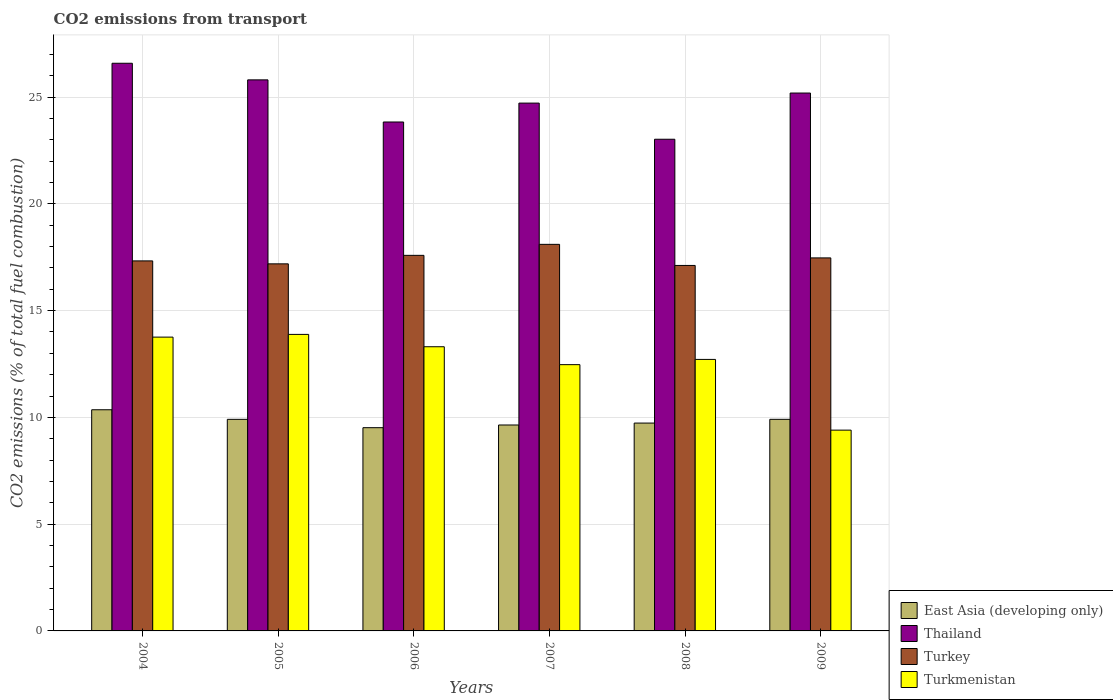How many different coloured bars are there?
Your response must be concise. 4. Are the number of bars per tick equal to the number of legend labels?
Make the answer very short. Yes. How many bars are there on the 5th tick from the left?
Make the answer very short. 4. How many bars are there on the 3rd tick from the right?
Offer a very short reply. 4. What is the label of the 6th group of bars from the left?
Give a very brief answer. 2009. In how many cases, is the number of bars for a given year not equal to the number of legend labels?
Your response must be concise. 0. What is the total CO2 emitted in Thailand in 2007?
Make the answer very short. 24.72. Across all years, what is the maximum total CO2 emitted in Turkey?
Offer a terse response. 18.1. Across all years, what is the minimum total CO2 emitted in Turkey?
Your answer should be very brief. 17.11. In which year was the total CO2 emitted in Thailand maximum?
Keep it short and to the point. 2004. What is the total total CO2 emitted in Turkmenistan in the graph?
Ensure brevity in your answer.  75.53. What is the difference between the total CO2 emitted in East Asia (developing only) in 2004 and that in 2008?
Give a very brief answer. 0.62. What is the difference between the total CO2 emitted in Turkmenistan in 2008 and the total CO2 emitted in East Asia (developing only) in 2005?
Your response must be concise. 2.81. What is the average total CO2 emitted in Turkey per year?
Ensure brevity in your answer.  17.46. In the year 2007, what is the difference between the total CO2 emitted in East Asia (developing only) and total CO2 emitted in Turkey?
Provide a short and direct response. -8.46. What is the ratio of the total CO2 emitted in Turkmenistan in 2004 to that in 2009?
Offer a very short reply. 1.46. Is the total CO2 emitted in East Asia (developing only) in 2005 less than that in 2009?
Ensure brevity in your answer.  Yes. What is the difference between the highest and the second highest total CO2 emitted in Turkey?
Ensure brevity in your answer.  0.52. What is the difference between the highest and the lowest total CO2 emitted in Thailand?
Keep it short and to the point. 3.56. In how many years, is the total CO2 emitted in Turkmenistan greater than the average total CO2 emitted in Turkmenistan taken over all years?
Offer a terse response. 4. Is the sum of the total CO2 emitted in Turkmenistan in 2005 and 2007 greater than the maximum total CO2 emitted in Turkey across all years?
Keep it short and to the point. Yes. Is it the case that in every year, the sum of the total CO2 emitted in Turkey and total CO2 emitted in East Asia (developing only) is greater than the sum of total CO2 emitted in Turkmenistan and total CO2 emitted in Thailand?
Keep it short and to the point. No. What does the 1st bar from the left in 2004 represents?
Provide a succinct answer. East Asia (developing only). What does the 4th bar from the right in 2005 represents?
Make the answer very short. East Asia (developing only). How many bars are there?
Give a very brief answer. 24. Are all the bars in the graph horizontal?
Ensure brevity in your answer.  No. How many years are there in the graph?
Provide a succinct answer. 6. Are the values on the major ticks of Y-axis written in scientific E-notation?
Offer a terse response. No. Where does the legend appear in the graph?
Your response must be concise. Bottom right. How many legend labels are there?
Provide a short and direct response. 4. What is the title of the graph?
Provide a succinct answer. CO2 emissions from transport. Does "Czech Republic" appear as one of the legend labels in the graph?
Offer a terse response. No. What is the label or title of the Y-axis?
Your answer should be compact. CO2 emissions (% of total fuel combustion). What is the CO2 emissions (% of total fuel combustion) in East Asia (developing only) in 2004?
Your response must be concise. 10.36. What is the CO2 emissions (% of total fuel combustion) of Thailand in 2004?
Your answer should be very brief. 26.58. What is the CO2 emissions (% of total fuel combustion) in Turkey in 2004?
Ensure brevity in your answer.  17.33. What is the CO2 emissions (% of total fuel combustion) in Turkmenistan in 2004?
Your answer should be very brief. 13.76. What is the CO2 emissions (% of total fuel combustion) in East Asia (developing only) in 2005?
Give a very brief answer. 9.91. What is the CO2 emissions (% of total fuel combustion) in Thailand in 2005?
Your answer should be compact. 25.8. What is the CO2 emissions (% of total fuel combustion) of Turkey in 2005?
Your answer should be compact. 17.19. What is the CO2 emissions (% of total fuel combustion) in Turkmenistan in 2005?
Give a very brief answer. 13.89. What is the CO2 emissions (% of total fuel combustion) of East Asia (developing only) in 2006?
Offer a terse response. 9.52. What is the CO2 emissions (% of total fuel combustion) of Thailand in 2006?
Give a very brief answer. 23.83. What is the CO2 emissions (% of total fuel combustion) of Turkey in 2006?
Make the answer very short. 17.59. What is the CO2 emissions (% of total fuel combustion) of Turkmenistan in 2006?
Give a very brief answer. 13.31. What is the CO2 emissions (% of total fuel combustion) of East Asia (developing only) in 2007?
Keep it short and to the point. 9.64. What is the CO2 emissions (% of total fuel combustion) in Thailand in 2007?
Provide a short and direct response. 24.72. What is the CO2 emissions (% of total fuel combustion) in Turkey in 2007?
Your answer should be compact. 18.1. What is the CO2 emissions (% of total fuel combustion) of Turkmenistan in 2007?
Your response must be concise. 12.47. What is the CO2 emissions (% of total fuel combustion) in East Asia (developing only) in 2008?
Your response must be concise. 9.73. What is the CO2 emissions (% of total fuel combustion) in Thailand in 2008?
Your response must be concise. 23.02. What is the CO2 emissions (% of total fuel combustion) in Turkey in 2008?
Your answer should be compact. 17.11. What is the CO2 emissions (% of total fuel combustion) in Turkmenistan in 2008?
Your answer should be compact. 12.71. What is the CO2 emissions (% of total fuel combustion) in East Asia (developing only) in 2009?
Ensure brevity in your answer.  9.91. What is the CO2 emissions (% of total fuel combustion) of Thailand in 2009?
Give a very brief answer. 25.19. What is the CO2 emissions (% of total fuel combustion) of Turkey in 2009?
Ensure brevity in your answer.  17.47. What is the CO2 emissions (% of total fuel combustion) of Turkmenistan in 2009?
Provide a short and direct response. 9.4. Across all years, what is the maximum CO2 emissions (% of total fuel combustion) of East Asia (developing only)?
Your answer should be very brief. 10.36. Across all years, what is the maximum CO2 emissions (% of total fuel combustion) in Thailand?
Your answer should be very brief. 26.58. Across all years, what is the maximum CO2 emissions (% of total fuel combustion) in Turkey?
Offer a very short reply. 18.1. Across all years, what is the maximum CO2 emissions (% of total fuel combustion) in Turkmenistan?
Your answer should be compact. 13.89. Across all years, what is the minimum CO2 emissions (% of total fuel combustion) in East Asia (developing only)?
Provide a short and direct response. 9.52. Across all years, what is the minimum CO2 emissions (% of total fuel combustion) in Thailand?
Your response must be concise. 23.02. Across all years, what is the minimum CO2 emissions (% of total fuel combustion) of Turkey?
Offer a terse response. 17.11. Across all years, what is the minimum CO2 emissions (% of total fuel combustion) in Turkmenistan?
Provide a succinct answer. 9.4. What is the total CO2 emissions (% of total fuel combustion) of East Asia (developing only) in the graph?
Offer a terse response. 59.07. What is the total CO2 emissions (% of total fuel combustion) in Thailand in the graph?
Give a very brief answer. 149.14. What is the total CO2 emissions (% of total fuel combustion) in Turkey in the graph?
Give a very brief answer. 104.79. What is the total CO2 emissions (% of total fuel combustion) of Turkmenistan in the graph?
Provide a succinct answer. 75.53. What is the difference between the CO2 emissions (% of total fuel combustion) of East Asia (developing only) in 2004 and that in 2005?
Keep it short and to the point. 0.45. What is the difference between the CO2 emissions (% of total fuel combustion) in Thailand in 2004 and that in 2005?
Your answer should be very brief. 0.78. What is the difference between the CO2 emissions (% of total fuel combustion) of Turkey in 2004 and that in 2005?
Offer a very short reply. 0.14. What is the difference between the CO2 emissions (% of total fuel combustion) in Turkmenistan in 2004 and that in 2005?
Make the answer very short. -0.13. What is the difference between the CO2 emissions (% of total fuel combustion) in East Asia (developing only) in 2004 and that in 2006?
Offer a terse response. 0.84. What is the difference between the CO2 emissions (% of total fuel combustion) in Thailand in 2004 and that in 2006?
Give a very brief answer. 2.75. What is the difference between the CO2 emissions (% of total fuel combustion) in Turkey in 2004 and that in 2006?
Your answer should be very brief. -0.26. What is the difference between the CO2 emissions (% of total fuel combustion) in Turkmenistan in 2004 and that in 2006?
Keep it short and to the point. 0.45. What is the difference between the CO2 emissions (% of total fuel combustion) of East Asia (developing only) in 2004 and that in 2007?
Your answer should be very brief. 0.71. What is the difference between the CO2 emissions (% of total fuel combustion) of Thailand in 2004 and that in 2007?
Offer a very short reply. 1.87. What is the difference between the CO2 emissions (% of total fuel combustion) in Turkey in 2004 and that in 2007?
Your answer should be compact. -0.78. What is the difference between the CO2 emissions (% of total fuel combustion) in Turkmenistan in 2004 and that in 2007?
Provide a short and direct response. 1.29. What is the difference between the CO2 emissions (% of total fuel combustion) in East Asia (developing only) in 2004 and that in 2008?
Provide a succinct answer. 0.62. What is the difference between the CO2 emissions (% of total fuel combustion) of Thailand in 2004 and that in 2008?
Your response must be concise. 3.56. What is the difference between the CO2 emissions (% of total fuel combustion) of Turkey in 2004 and that in 2008?
Provide a short and direct response. 0.21. What is the difference between the CO2 emissions (% of total fuel combustion) in Turkmenistan in 2004 and that in 2008?
Your answer should be very brief. 1.04. What is the difference between the CO2 emissions (% of total fuel combustion) of East Asia (developing only) in 2004 and that in 2009?
Your answer should be compact. 0.45. What is the difference between the CO2 emissions (% of total fuel combustion) in Thailand in 2004 and that in 2009?
Your answer should be compact. 1.39. What is the difference between the CO2 emissions (% of total fuel combustion) in Turkey in 2004 and that in 2009?
Your answer should be compact. -0.14. What is the difference between the CO2 emissions (% of total fuel combustion) of Turkmenistan in 2004 and that in 2009?
Ensure brevity in your answer.  4.36. What is the difference between the CO2 emissions (% of total fuel combustion) in East Asia (developing only) in 2005 and that in 2006?
Keep it short and to the point. 0.39. What is the difference between the CO2 emissions (% of total fuel combustion) in Thailand in 2005 and that in 2006?
Offer a terse response. 1.97. What is the difference between the CO2 emissions (% of total fuel combustion) in Turkey in 2005 and that in 2006?
Ensure brevity in your answer.  -0.4. What is the difference between the CO2 emissions (% of total fuel combustion) of Turkmenistan in 2005 and that in 2006?
Provide a short and direct response. 0.58. What is the difference between the CO2 emissions (% of total fuel combustion) in East Asia (developing only) in 2005 and that in 2007?
Your answer should be compact. 0.26. What is the difference between the CO2 emissions (% of total fuel combustion) in Thailand in 2005 and that in 2007?
Provide a short and direct response. 1.09. What is the difference between the CO2 emissions (% of total fuel combustion) in Turkey in 2005 and that in 2007?
Make the answer very short. -0.91. What is the difference between the CO2 emissions (% of total fuel combustion) of Turkmenistan in 2005 and that in 2007?
Ensure brevity in your answer.  1.42. What is the difference between the CO2 emissions (% of total fuel combustion) in East Asia (developing only) in 2005 and that in 2008?
Offer a terse response. 0.17. What is the difference between the CO2 emissions (% of total fuel combustion) of Thailand in 2005 and that in 2008?
Give a very brief answer. 2.78. What is the difference between the CO2 emissions (% of total fuel combustion) of Turkey in 2005 and that in 2008?
Offer a very short reply. 0.08. What is the difference between the CO2 emissions (% of total fuel combustion) in Turkmenistan in 2005 and that in 2008?
Provide a succinct answer. 1.17. What is the difference between the CO2 emissions (% of total fuel combustion) of East Asia (developing only) in 2005 and that in 2009?
Offer a very short reply. -0. What is the difference between the CO2 emissions (% of total fuel combustion) in Thailand in 2005 and that in 2009?
Your answer should be compact. 0.62. What is the difference between the CO2 emissions (% of total fuel combustion) of Turkey in 2005 and that in 2009?
Your response must be concise. -0.28. What is the difference between the CO2 emissions (% of total fuel combustion) of Turkmenistan in 2005 and that in 2009?
Your answer should be compact. 4.48. What is the difference between the CO2 emissions (% of total fuel combustion) in East Asia (developing only) in 2006 and that in 2007?
Offer a terse response. -0.13. What is the difference between the CO2 emissions (% of total fuel combustion) of Thailand in 2006 and that in 2007?
Your answer should be very brief. -0.88. What is the difference between the CO2 emissions (% of total fuel combustion) in Turkey in 2006 and that in 2007?
Provide a succinct answer. -0.52. What is the difference between the CO2 emissions (% of total fuel combustion) in Turkmenistan in 2006 and that in 2007?
Provide a succinct answer. 0.84. What is the difference between the CO2 emissions (% of total fuel combustion) of East Asia (developing only) in 2006 and that in 2008?
Provide a short and direct response. -0.22. What is the difference between the CO2 emissions (% of total fuel combustion) in Thailand in 2006 and that in 2008?
Ensure brevity in your answer.  0.81. What is the difference between the CO2 emissions (% of total fuel combustion) of Turkey in 2006 and that in 2008?
Your response must be concise. 0.47. What is the difference between the CO2 emissions (% of total fuel combustion) in Turkmenistan in 2006 and that in 2008?
Offer a terse response. 0.59. What is the difference between the CO2 emissions (% of total fuel combustion) of East Asia (developing only) in 2006 and that in 2009?
Provide a short and direct response. -0.39. What is the difference between the CO2 emissions (% of total fuel combustion) of Thailand in 2006 and that in 2009?
Make the answer very short. -1.36. What is the difference between the CO2 emissions (% of total fuel combustion) of Turkey in 2006 and that in 2009?
Offer a terse response. 0.12. What is the difference between the CO2 emissions (% of total fuel combustion) in Turkmenistan in 2006 and that in 2009?
Your answer should be very brief. 3.91. What is the difference between the CO2 emissions (% of total fuel combustion) of East Asia (developing only) in 2007 and that in 2008?
Keep it short and to the point. -0.09. What is the difference between the CO2 emissions (% of total fuel combustion) in Thailand in 2007 and that in 2008?
Your response must be concise. 1.69. What is the difference between the CO2 emissions (% of total fuel combustion) of Turkey in 2007 and that in 2008?
Offer a terse response. 0.99. What is the difference between the CO2 emissions (% of total fuel combustion) of Turkmenistan in 2007 and that in 2008?
Give a very brief answer. -0.24. What is the difference between the CO2 emissions (% of total fuel combustion) of East Asia (developing only) in 2007 and that in 2009?
Offer a terse response. -0.27. What is the difference between the CO2 emissions (% of total fuel combustion) of Thailand in 2007 and that in 2009?
Keep it short and to the point. -0.47. What is the difference between the CO2 emissions (% of total fuel combustion) in Turkey in 2007 and that in 2009?
Keep it short and to the point. 0.63. What is the difference between the CO2 emissions (% of total fuel combustion) of Turkmenistan in 2007 and that in 2009?
Give a very brief answer. 3.07. What is the difference between the CO2 emissions (% of total fuel combustion) in East Asia (developing only) in 2008 and that in 2009?
Offer a very short reply. -0.18. What is the difference between the CO2 emissions (% of total fuel combustion) in Thailand in 2008 and that in 2009?
Offer a terse response. -2.16. What is the difference between the CO2 emissions (% of total fuel combustion) of Turkey in 2008 and that in 2009?
Provide a short and direct response. -0.35. What is the difference between the CO2 emissions (% of total fuel combustion) of Turkmenistan in 2008 and that in 2009?
Give a very brief answer. 3.31. What is the difference between the CO2 emissions (% of total fuel combustion) in East Asia (developing only) in 2004 and the CO2 emissions (% of total fuel combustion) in Thailand in 2005?
Your answer should be very brief. -15.45. What is the difference between the CO2 emissions (% of total fuel combustion) of East Asia (developing only) in 2004 and the CO2 emissions (% of total fuel combustion) of Turkey in 2005?
Your response must be concise. -6.83. What is the difference between the CO2 emissions (% of total fuel combustion) of East Asia (developing only) in 2004 and the CO2 emissions (% of total fuel combustion) of Turkmenistan in 2005?
Keep it short and to the point. -3.53. What is the difference between the CO2 emissions (% of total fuel combustion) of Thailand in 2004 and the CO2 emissions (% of total fuel combustion) of Turkey in 2005?
Your response must be concise. 9.39. What is the difference between the CO2 emissions (% of total fuel combustion) in Thailand in 2004 and the CO2 emissions (% of total fuel combustion) in Turkmenistan in 2005?
Offer a terse response. 12.7. What is the difference between the CO2 emissions (% of total fuel combustion) of Turkey in 2004 and the CO2 emissions (% of total fuel combustion) of Turkmenistan in 2005?
Your answer should be compact. 3.44. What is the difference between the CO2 emissions (% of total fuel combustion) in East Asia (developing only) in 2004 and the CO2 emissions (% of total fuel combustion) in Thailand in 2006?
Make the answer very short. -13.48. What is the difference between the CO2 emissions (% of total fuel combustion) of East Asia (developing only) in 2004 and the CO2 emissions (% of total fuel combustion) of Turkey in 2006?
Ensure brevity in your answer.  -7.23. What is the difference between the CO2 emissions (% of total fuel combustion) in East Asia (developing only) in 2004 and the CO2 emissions (% of total fuel combustion) in Turkmenistan in 2006?
Your answer should be compact. -2.95. What is the difference between the CO2 emissions (% of total fuel combustion) of Thailand in 2004 and the CO2 emissions (% of total fuel combustion) of Turkey in 2006?
Provide a short and direct response. 8.99. What is the difference between the CO2 emissions (% of total fuel combustion) in Thailand in 2004 and the CO2 emissions (% of total fuel combustion) in Turkmenistan in 2006?
Make the answer very short. 13.27. What is the difference between the CO2 emissions (% of total fuel combustion) of Turkey in 2004 and the CO2 emissions (% of total fuel combustion) of Turkmenistan in 2006?
Offer a very short reply. 4.02. What is the difference between the CO2 emissions (% of total fuel combustion) of East Asia (developing only) in 2004 and the CO2 emissions (% of total fuel combustion) of Thailand in 2007?
Your answer should be very brief. -14.36. What is the difference between the CO2 emissions (% of total fuel combustion) in East Asia (developing only) in 2004 and the CO2 emissions (% of total fuel combustion) in Turkey in 2007?
Offer a very short reply. -7.75. What is the difference between the CO2 emissions (% of total fuel combustion) of East Asia (developing only) in 2004 and the CO2 emissions (% of total fuel combustion) of Turkmenistan in 2007?
Provide a succinct answer. -2.11. What is the difference between the CO2 emissions (% of total fuel combustion) in Thailand in 2004 and the CO2 emissions (% of total fuel combustion) in Turkey in 2007?
Offer a terse response. 8.48. What is the difference between the CO2 emissions (% of total fuel combustion) of Thailand in 2004 and the CO2 emissions (% of total fuel combustion) of Turkmenistan in 2007?
Your answer should be compact. 14.11. What is the difference between the CO2 emissions (% of total fuel combustion) in Turkey in 2004 and the CO2 emissions (% of total fuel combustion) in Turkmenistan in 2007?
Make the answer very short. 4.86. What is the difference between the CO2 emissions (% of total fuel combustion) in East Asia (developing only) in 2004 and the CO2 emissions (% of total fuel combustion) in Thailand in 2008?
Your answer should be compact. -12.67. What is the difference between the CO2 emissions (% of total fuel combustion) of East Asia (developing only) in 2004 and the CO2 emissions (% of total fuel combustion) of Turkey in 2008?
Your response must be concise. -6.76. What is the difference between the CO2 emissions (% of total fuel combustion) in East Asia (developing only) in 2004 and the CO2 emissions (% of total fuel combustion) in Turkmenistan in 2008?
Offer a very short reply. -2.36. What is the difference between the CO2 emissions (% of total fuel combustion) of Thailand in 2004 and the CO2 emissions (% of total fuel combustion) of Turkey in 2008?
Your answer should be very brief. 9.47. What is the difference between the CO2 emissions (% of total fuel combustion) of Thailand in 2004 and the CO2 emissions (% of total fuel combustion) of Turkmenistan in 2008?
Keep it short and to the point. 13.87. What is the difference between the CO2 emissions (% of total fuel combustion) in Turkey in 2004 and the CO2 emissions (% of total fuel combustion) in Turkmenistan in 2008?
Your answer should be compact. 4.61. What is the difference between the CO2 emissions (% of total fuel combustion) in East Asia (developing only) in 2004 and the CO2 emissions (% of total fuel combustion) in Thailand in 2009?
Provide a short and direct response. -14.83. What is the difference between the CO2 emissions (% of total fuel combustion) in East Asia (developing only) in 2004 and the CO2 emissions (% of total fuel combustion) in Turkey in 2009?
Your response must be concise. -7.11. What is the difference between the CO2 emissions (% of total fuel combustion) in East Asia (developing only) in 2004 and the CO2 emissions (% of total fuel combustion) in Turkmenistan in 2009?
Provide a short and direct response. 0.95. What is the difference between the CO2 emissions (% of total fuel combustion) in Thailand in 2004 and the CO2 emissions (% of total fuel combustion) in Turkey in 2009?
Your answer should be compact. 9.11. What is the difference between the CO2 emissions (% of total fuel combustion) in Thailand in 2004 and the CO2 emissions (% of total fuel combustion) in Turkmenistan in 2009?
Offer a very short reply. 17.18. What is the difference between the CO2 emissions (% of total fuel combustion) in Turkey in 2004 and the CO2 emissions (% of total fuel combustion) in Turkmenistan in 2009?
Your response must be concise. 7.92. What is the difference between the CO2 emissions (% of total fuel combustion) of East Asia (developing only) in 2005 and the CO2 emissions (% of total fuel combustion) of Thailand in 2006?
Your answer should be compact. -13.92. What is the difference between the CO2 emissions (% of total fuel combustion) in East Asia (developing only) in 2005 and the CO2 emissions (% of total fuel combustion) in Turkey in 2006?
Make the answer very short. -7.68. What is the difference between the CO2 emissions (% of total fuel combustion) of East Asia (developing only) in 2005 and the CO2 emissions (% of total fuel combustion) of Turkmenistan in 2006?
Keep it short and to the point. -3.4. What is the difference between the CO2 emissions (% of total fuel combustion) of Thailand in 2005 and the CO2 emissions (% of total fuel combustion) of Turkey in 2006?
Provide a short and direct response. 8.22. What is the difference between the CO2 emissions (% of total fuel combustion) of Thailand in 2005 and the CO2 emissions (% of total fuel combustion) of Turkmenistan in 2006?
Provide a short and direct response. 12.5. What is the difference between the CO2 emissions (% of total fuel combustion) of Turkey in 2005 and the CO2 emissions (% of total fuel combustion) of Turkmenistan in 2006?
Your answer should be compact. 3.88. What is the difference between the CO2 emissions (% of total fuel combustion) of East Asia (developing only) in 2005 and the CO2 emissions (% of total fuel combustion) of Thailand in 2007?
Give a very brief answer. -14.81. What is the difference between the CO2 emissions (% of total fuel combustion) in East Asia (developing only) in 2005 and the CO2 emissions (% of total fuel combustion) in Turkey in 2007?
Make the answer very short. -8.19. What is the difference between the CO2 emissions (% of total fuel combustion) in East Asia (developing only) in 2005 and the CO2 emissions (% of total fuel combustion) in Turkmenistan in 2007?
Make the answer very short. -2.56. What is the difference between the CO2 emissions (% of total fuel combustion) of Thailand in 2005 and the CO2 emissions (% of total fuel combustion) of Turkey in 2007?
Offer a terse response. 7.7. What is the difference between the CO2 emissions (% of total fuel combustion) in Thailand in 2005 and the CO2 emissions (% of total fuel combustion) in Turkmenistan in 2007?
Provide a succinct answer. 13.34. What is the difference between the CO2 emissions (% of total fuel combustion) of Turkey in 2005 and the CO2 emissions (% of total fuel combustion) of Turkmenistan in 2007?
Your response must be concise. 4.72. What is the difference between the CO2 emissions (% of total fuel combustion) of East Asia (developing only) in 2005 and the CO2 emissions (% of total fuel combustion) of Thailand in 2008?
Provide a succinct answer. -13.12. What is the difference between the CO2 emissions (% of total fuel combustion) of East Asia (developing only) in 2005 and the CO2 emissions (% of total fuel combustion) of Turkey in 2008?
Ensure brevity in your answer.  -7.21. What is the difference between the CO2 emissions (% of total fuel combustion) in East Asia (developing only) in 2005 and the CO2 emissions (% of total fuel combustion) in Turkmenistan in 2008?
Your answer should be very brief. -2.81. What is the difference between the CO2 emissions (% of total fuel combustion) of Thailand in 2005 and the CO2 emissions (% of total fuel combustion) of Turkey in 2008?
Your response must be concise. 8.69. What is the difference between the CO2 emissions (% of total fuel combustion) of Thailand in 2005 and the CO2 emissions (% of total fuel combustion) of Turkmenistan in 2008?
Offer a very short reply. 13.09. What is the difference between the CO2 emissions (% of total fuel combustion) of Turkey in 2005 and the CO2 emissions (% of total fuel combustion) of Turkmenistan in 2008?
Give a very brief answer. 4.48. What is the difference between the CO2 emissions (% of total fuel combustion) of East Asia (developing only) in 2005 and the CO2 emissions (% of total fuel combustion) of Thailand in 2009?
Provide a succinct answer. -15.28. What is the difference between the CO2 emissions (% of total fuel combustion) in East Asia (developing only) in 2005 and the CO2 emissions (% of total fuel combustion) in Turkey in 2009?
Provide a short and direct response. -7.56. What is the difference between the CO2 emissions (% of total fuel combustion) of East Asia (developing only) in 2005 and the CO2 emissions (% of total fuel combustion) of Turkmenistan in 2009?
Offer a terse response. 0.51. What is the difference between the CO2 emissions (% of total fuel combustion) in Thailand in 2005 and the CO2 emissions (% of total fuel combustion) in Turkey in 2009?
Make the answer very short. 8.34. What is the difference between the CO2 emissions (% of total fuel combustion) of Thailand in 2005 and the CO2 emissions (% of total fuel combustion) of Turkmenistan in 2009?
Make the answer very short. 16.4. What is the difference between the CO2 emissions (% of total fuel combustion) of Turkey in 2005 and the CO2 emissions (% of total fuel combustion) of Turkmenistan in 2009?
Your answer should be compact. 7.79. What is the difference between the CO2 emissions (% of total fuel combustion) of East Asia (developing only) in 2006 and the CO2 emissions (% of total fuel combustion) of Thailand in 2007?
Provide a succinct answer. -15.2. What is the difference between the CO2 emissions (% of total fuel combustion) in East Asia (developing only) in 2006 and the CO2 emissions (% of total fuel combustion) in Turkey in 2007?
Offer a very short reply. -8.58. What is the difference between the CO2 emissions (% of total fuel combustion) of East Asia (developing only) in 2006 and the CO2 emissions (% of total fuel combustion) of Turkmenistan in 2007?
Give a very brief answer. -2.95. What is the difference between the CO2 emissions (% of total fuel combustion) of Thailand in 2006 and the CO2 emissions (% of total fuel combustion) of Turkey in 2007?
Ensure brevity in your answer.  5.73. What is the difference between the CO2 emissions (% of total fuel combustion) in Thailand in 2006 and the CO2 emissions (% of total fuel combustion) in Turkmenistan in 2007?
Ensure brevity in your answer.  11.36. What is the difference between the CO2 emissions (% of total fuel combustion) in Turkey in 2006 and the CO2 emissions (% of total fuel combustion) in Turkmenistan in 2007?
Offer a very short reply. 5.12. What is the difference between the CO2 emissions (% of total fuel combustion) of East Asia (developing only) in 2006 and the CO2 emissions (% of total fuel combustion) of Thailand in 2008?
Make the answer very short. -13.51. What is the difference between the CO2 emissions (% of total fuel combustion) in East Asia (developing only) in 2006 and the CO2 emissions (% of total fuel combustion) in Turkey in 2008?
Your answer should be compact. -7.6. What is the difference between the CO2 emissions (% of total fuel combustion) in East Asia (developing only) in 2006 and the CO2 emissions (% of total fuel combustion) in Turkmenistan in 2008?
Offer a terse response. -3.2. What is the difference between the CO2 emissions (% of total fuel combustion) in Thailand in 2006 and the CO2 emissions (% of total fuel combustion) in Turkey in 2008?
Your answer should be very brief. 6.72. What is the difference between the CO2 emissions (% of total fuel combustion) of Thailand in 2006 and the CO2 emissions (% of total fuel combustion) of Turkmenistan in 2008?
Ensure brevity in your answer.  11.12. What is the difference between the CO2 emissions (% of total fuel combustion) in Turkey in 2006 and the CO2 emissions (% of total fuel combustion) in Turkmenistan in 2008?
Keep it short and to the point. 4.87. What is the difference between the CO2 emissions (% of total fuel combustion) in East Asia (developing only) in 2006 and the CO2 emissions (% of total fuel combustion) in Thailand in 2009?
Give a very brief answer. -15.67. What is the difference between the CO2 emissions (% of total fuel combustion) in East Asia (developing only) in 2006 and the CO2 emissions (% of total fuel combustion) in Turkey in 2009?
Make the answer very short. -7.95. What is the difference between the CO2 emissions (% of total fuel combustion) in East Asia (developing only) in 2006 and the CO2 emissions (% of total fuel combustion) in Turkmenistan in 2009?
Provide a succinct answer. 0.12. What is the difference between the CO2 emissions (% of total fuel combustion) in Thailand in 2006 and the CO2 emissions (% of total fuel combustion) in Turkey in 2009?
Make the answer very short. 6.36. What is the difference between the CO2 emissions (% of total fuel combustion) of Thailand in 2006 and the CO2 emissions (% of total fuel combustion) of Turkmenistan in 2009?
Offer a very short reply. 14.43. What is the difference between the CO2 emissions (% of total fuel combustion) of Turkey in 2006 and the CO2 emissions (% of total fuel combustion) of Turkmenistan in 2009?
Make the answer very short. 8.18. What is the difference between the CO2 emissions (% of total fuel combustion) in East Asia (developing only) in 2007 and the CO2 emissions (% of total fuel combustion) in Thailand in 2008?
Your response must be concise. -13.38. What is the difference between the CO2 emissions (% of total fuel combustion) in East Asia (developing only) in 2007 and the CO2 emissions (% of total fuel combustion) in Turkey in 2008?
Make the answer very short. -7.47. What is the difference between the CO2 emissions (% of total fuel combustion) of East Asia (developing only) in 2007 and the CO2 emissions (% of total fuel combustion) of Turkmenistan in 2008?
Your answer should be compact. -3.07. What is the difference between the CO2 emissions (% of total fuel combustion) of Thailand in 2007 and the CO2 emissions (% of total fuel combustion) of Turkey in 2008?
Give a very brief answer. 7.6. What is the difference between the CO2 emissions (% of total fuel combustion) in Thailand in 2007 and the CO2 emissions (% of total fuel combustion) in Turkmenistan in 2008?
Your answer should be very brief. 12. What is the difference between the CO2 emissions (% of total fuel combustion) in Turkey in 2007 and the CO2 emissions (% of total fuel combustion) in Turkmenistan in 2008?
Ensure brevity in your answer.  5.39. What is the difference between the CO2 emissions (% of total fuel combustion) of East Asia (developing only) in 2007 and the CO2 emissions (% of total fuel combustion) of Thailand in 2009?
Offer a very short reply. -15.54. What is the difference between the CO2 emissions (% of total fuel combustion) in East Asia (developing only) in 2007 and the CO2 emissions (% of total fuel combustion) in Turkey in 2009?
Offer a very short reply. -7.82. What is the difference between the CO2 emissions (% of total fuel combustion) of East Asia (developing only) in 2007 and the CO2 emissions (% of total fuel combustion) of Turkmenistan in 2009?
Provide a short and direct response. 0.24. What is the difference between the CO2 emissions (% of total fuel combustion) of Thailand in 2007 and the CO2 emissions (% of total fuel combustion) of Turkey in 2009?
Make the answer very short. 7.25. What is the difference between the CO2 emissions (% of total fuel combustion) of Thailand in 2007 and the CO2 emissions (% of total fuel combustion) of Turkmenistan in 2009?
Offer a very short reply. 15.31. What is the difference between the CO2 emissions (% of total fuel combustion) in Turkey in 2007 and the CO2 emissions (% of total fuel combustion) in Turkmenistan in 2009?
Your response must be concise. 8.7. What is the difference between the CO2 emissions (% of total fuel combustion) in East Asia (developing only) in 2008 and the CO2 emissions (% of total fuel combustion) in Thailand in 2009?
Offer a terse response. -15.45. What is the difference between the CO2 emissions (% of total fuel combustion) of East Asia (developing only) in 2008 and the CO2 emissions (% of total fuel combustion) of Turkey in 2009?
Provide a succinct answer. -7.73. What is the difference between the CO2 emissions (% of total fuel combustion) of East Asia (developing only) in 2008 and the CO2 emissions (% of total fuel combustion) of Turkmenistan in 2009?
Provide a short and direct response. 0.33. What is the difference between the CO2 emissions (% of total fuel combustion) in Thailand in 2008 and the CO2 emissions (% of total fuel combustion) in Turkey in 2009?
Offer a very short reply. 5.56. What is the difference between the CO2 emissions (% of total fuel combustion) of Thailand in 2008 and the CO2 emissions (% of total fuel combustion) of Turkmenistan in 2009?
Ensure brevity in your answer.  13.62. What is the difference between the CO2 emissions (% of total fuel combustion) of Turkey in 2008 and the CO2 emissions (% of total fuel combustion) of Turkmenistan in 2009?
Ensure brevity in your answer.  7.71. What is the average CO2 emissions (% of total fuel combustion) of East Asia (developing only) per year?
Make the answer very short. 9.84. What is the average CO2 emissions (% of total fuel combustion) of Thailand per year?
Provide a short and direct response. 24.86. What is the average CO2 emissions (% of total fuel combustion) in Turkey per year?
Offer a terse response. 17.46. What is the average CO2 emissions (% of total fuel combustion) of Turkmenistan per year?
Provide a short and direct response. 12.59. In the year 2004, what is the difference between the CO2 emissions (% of total fuel combustion) in East Asia (developing only) and CO2 emissions (% of total fuel combustion) in Thailand?
Your answer should be very brief. -16.23. In the year 2004, what is the difference between the CO2 emissions (% of total fuel combustion) of East Asia (developing only) and CO2 emissions (% of total fuel combustion) of Turkey?
Offer a terse response. -6.97. In the year 2004, what is the difference between the CO2 emissions (% of total fuel combustion) of East Asia (developing only) and CO2 emissions (% of total fuel combustion) of Turkmenistan?
Provide a short and direct response. -3.4. In the year 2004, what is the difference between the CO2 emissions (% of total fuel combustion) of Thailand and CO2 emissions (% of total fuel combustion) of Turkey?
Ensure brevity in your answer.  9.25. In the year 2004, what is the difference between the CO2 emissions (% of total fuel combustion) in Thailand and CO2 emissions (% of total fuel combustion) in Turkmenistan?
Make the answer very short. 12.82. In the year 2004, what is the difference between the CO2 emissions (% of total fuel combustion) in Turkey and CO2 emissions (% of total fuel combustion) in Turkmenistan?
Offer a very short reply. 3.57. In the year 2005, what is the difference between the CO2 emissions (% of total fuel combustion) of East Asia (developing only) and CO2 emissions (% of total fuel combustion) of Thailand?
Provide a short and direct response. -15.9. In the year 2005, what is the difference between the CO2 emissions (% of total fuel combustion) in East Asia (developing only) and CO2 emissions (% of total fuel combustion) in Turkey?
Provide a succinct answer. -7.28. In the year 2005, what is the difference between the CO2 emissions (% of total fuel combustion) in East Asia (developing only) and CO2 emissions (% of total fuel combustion) in Turkmenistan?
Your answer should be very brief. -3.98. In the year 2005, what is the difference between the CO2 emissions (% of total fuel combustion) in Thailand and CO2 emissions (% of total fuel combustion) in Turkey?
Provide a succinct answer. 8.62. In the year 2005, what is the difference between the CO2 emissions (% of total fuel combustion) in Thailand and CO2 emissions (% of total fuel combustion) in Turkmenistan?
Keep it short and to the point. 11.92. In the year 2005, what is the difference between the CO2 emissions (% of total fuel combustion) in Turkey and CO2 emissions (% of total fuel combustion) in Turkmenistan?
Offer a very short reply. 3.3. In the year 2006, what is the difference between the CO2 emissions (% of total fuel combustion) of East Asia (developing only) and CO2 emissions (% of total fuel combustion) of Thailand?
Provide a short and direct response. -14.31. In the year 2006, what is the difference between the CO2 emissions (% of total fuel combustion) in East Asia (developing only) and CO2 emissions (% of total fuel combustion) in Turkey?
Provide a short and direct response. -8.07. In the year 2006, what is the difference between the CO2 emissions (% of total fuel combustion) of East Asia (developing only) and CO2 emissions (% of total fuel combustion) of Turkmenistan?
Your answer should be very brief. -3.79. In the year 2006, what is the difference between the CO2 emissions (% of total fuel combustion) in Thailand and CO2 emissions (% of total fuel combustion) in Turkey?
Your answer should be compact. 6.25. In the year 2006, what is the difference between the CO2 emissions (% of total fuel combustion) in Thailand and CO2 emissions (% of total fuel combustion) in Turkmenistan?
Offer a terse response. 10.52. In the year 2006, what is the difference between the CO2 emissions (% of total fuel combustion) of Turkey and CO2 emissions (% of total fuel combustion) of Turkmenistan?
Offer a terse response. 4.28. In the year 2007, what is the difference between the CO2 emissions (% of total fuel combustion) of East Asia (developing only) and CO2 emissions (% of total fuel combustion) of Thailand?
Offer a terse response. -15.07. In the year 2007, what is the difference between the CO2 emissions (% of total fuel combustion) in East Asia (developing only) and CO2 emissions (% of total fuel combustion) in Turkey?
Make the answer very short. -8.46. In the year 2007, what is the difference between the CO2 emissions (% of total fuel combustion) in East Asia (developing only) and CO2 emissions (% of total fuel combustion) in Turkmenistan?
Give a very brief answer. -2.83. In the year 2007, what is the difference between the CO2 emissions (% of total fuel combustion) of Thailand and CO2 emissions (% of total fuel combustion) of Turkey?
Give a very brief answer. 6.61. In the year 2007, what is the difference between the CO2 emissions (% of total fuel combustion) of Thailand and CO2 emissions (% of total fuel combustion) of Turkmenistan?
Make the answer very short. 12.25. In the year 2007, what is the difference between the CO2 emissions (% of total fuel combustion) of Turkey and CO2 emissions (% of total fuel combustion) of Turkmenistan?
Keep it short and to the point. 5.63. In the year 2008, what is the difference between the CO2 emissions (% of total fuel combustion) of East Asia (developing only) and CO2 emissions (% of total fuel combustion) of Thailand?
Offer a very short reply. -13.29. In the year 2008, what is the difference between the CO2 emissions (% of total fuel combustion) of East Asia (developing only) and CO2 emissions (% of total fuel combustion) of Turkey?
Ensure brevity in your answer.  -7.38. In the year 2008, what is the difference between the CO2 emissions (% of total fuel combustion) in East Asia (developing only) and CO2 emissions (% of total fuel combustion) in Turkmenistan?
Ensure brevity in your answer.  -2.98. In the year 2008, what is the difference between the CO2 emissions (% of total fuel combustion) of Thailand and CO2 emissions (% of total fuel combustion) of Turkey?
Offer a very short reply. 5.91. In the year 2008, what is the difference between the CO2 emissions (% of total fuel combustion) of Thailand and CO2 emissions (% of total fuel combustion) of Turkmenistan?
Keep it short and to the point. 10.31. In the year 2008, what is the difference between the CO2 emissions (% of total fuel combustion) in Turkey and CO2 emissions (% of total fuel combustion) in Turkmenistan?
Ensure brevity in your answer.  4.4. In the year 2009, what is the difference between the CO2 emissions (% of total fuel combustion) in East Asia (developing only) and CO2 emissions (% of total fuel combustion) in Thailand?
Your response must be concise. -15.28. In the year 2009, what is the difference between the CO2 emissions (% of total fuel combustion) of East Asia (developing only) and CO2 emissions (% of total fuel combustion) of Turkey?
Your answer should be very brief. -7.56. In the year 2009, what is the difference between the CO2 emissions (% of total fuel combustion) of East Asia (developing only) and CO2 emissions (% of total fuel combustion) of Turkmenistan?
Keep it short and to the point. 0.51. In the year 2009, what is the difference between the CO2 emissions (% of total fuel combustion) of Thailand and CO2 emissions (% of total fuel combustion) of Turkey?
Your response must be concise. 7.72. In the year 2009, what is the difference between the CO2 emissions (% of total fuel combustion) in Thailand and CO2 emissions (% of total fuel combustion) in Turkmenistan?
Provide a succinct answer. 15.78. In the year 2009, what is the difference between the CO2 emissions (% of total fuel combustion) of Turkey and CO2 emissions (% of total fuel combustion) of Turkmenistan?
Provide a short and direct response. 8.07. What is the ratio of the CO2 emissions (% of total fuel combustion) in East Asia (developing only) in 2004 to that in 2005?
Your response must be concise. 1.05. What is the ratio of the CO2 emissions (% of total fuel combustion) of Thailand in 2004 to that in 2005?
Your answer should be very brief. 1.03. What is the ratio of the CO2 emissions (% of total fuel combustion) of East Asia (developing only) in 2004 to that in 2006?
Provide a succinct answer. 1.09. What is the ratio of the CO2 emissions (% of total fuel combustion) in Thailand in 2004 to that in 2006?
Keep it short and to the point. 1.12. What is the ratio of the CO2 emissions (% of total fuel combustion) of Turkey in 2004 to that in 2006?
Your answer should be compact. 0.99. What is the ratio of the CO2 emissions (% of total fuel combustion) in Turkmenistan in 2004 to that in 2006?
Keep it short and to the point. 1.03. What is the ratio of the CO2 emissions (% of total fuel combustion) in East Asia (developing only) in 2004 to that in 2007?
Offer a terse response. 1.07. What is the ratio of the CO2 emissions (% of total fuel combustion) in Thailand in 2004 to that in 2007?
Your answer should be very brief. 1.08. What is the ratio of the CO2 emissions (% of total fuel combustion) of Turkey in 2004 to that in 2007?
Provide a short and direct response. 0.96. What is the ratio of the CO2 emissions (% of total fuel combustion) of Turkmenistan in 2004 to that in 2007?
Offer a terse response. 1.1. What is the ratio of the CO2 emissions (% of total fuel combustion) in East Asia (developing only) in 2004 to that in 2008?
Give a very brief answer. 1.06. What is the ratio of the CO2 emissions (% of total fuel combustion) of Thailand in 2004 to that in 2008?
Offer a terse response. 1.15. What is the ratio of the CO2 emissions (% of total fuel combustion) in Turkey in 2004 to that in 2008?
Offer a terse response. 1.01. What is the ratio of the CO2 emissions (% of total fuel combustion) in Turkmenistan in 2004 to that in 2008?
Provide a short and direct response. 1.08. What is the ratio of the CO2 emissions (% of total fuel combustion) in East Asia (developing only) in 2004 to that in 2009?
Offer a very short reply. 1.05. What is the ratio of the CO2 emissions (% of total fuel combustion) of Thailand in 2004 to that in 2009?
Your answer should be compact. 1.06. What is the ratio of the CO2 emissions (% of total fuel combustion) in Turkmenistan in 2004 to that in 2009?
Keep it short and to the point. 1.46. What is the ratio of the CO2 emissions (% of total fuel combustion) of East Asia (developing only) in 2005 to that in 2006?
Offer a very short reply. 1.04. What is the ratio of the CO2 emissions (% of total fuel combustion) of Thailand in 2005 to that in 2006?
Your answer should be very brief. 1.08. What is the ratio of the CO2 emissions (% of total fuel combustion) in Turkey in 2005 to that in 2006?
Offer a very short reply. 0.98. What is the ratio of the CO2 emissions (% of total fuel combustion) of Turkmenistan in 2005 to that in 2006?
Your response must be concise. 1.04. What is the ratio of the CO2 emissions (% of total fuel combustion) in East Asia (developing only) in 2005 to that in 2007?
Your answer should be compact. 1.03. What is the ratio of the CO2 emissions (% of total fuel combustion) in Thailand in 2005 to that in 2007?
Give a very brief answer. 1.04. What is the ratio of the CO2 emissions (% of total fuel combustion) in Turkey in 2005 to that in 2007?
Keep it short and to the point. 0.95. What is the ratio of the CO2 emissions (% of total fuel combustion) in Turkmenistan in 2005 to that in 2007?
Give a very brief answer. 1.11. What is the ratio of the CO2 emissions (% of total fuel combustion) in Thailand in 2005 to that in 2008?
Provide a succinct answer. 1.12. What is the ratio of the CO2 emissions (% of total fuel combustion) in Turkey in 2005 to that in 2008?
Your response must be concise. 1. What is the ratio of the CO2 emissions (% of total fuel combustion) of Turkmenistan in 2005 to that in 2008?
Offer a terse response. 1.09. What is the ratio of the CO2 emissions (% of total fuel combustion) in East Asia (developing only) in 2005 to that in 2009?
Give a very brief answer. 1. What is the ratio of the CO2 emissions (% of total fuel combustion) of Thailand in 2005 to that in 2009?
Offer a very short reply. 1.02. What is the ratio of the CO2 emissions (% of total fuel combustion) in Turkey in 2005 to that in 2009?
Give a very brief answer. 0.98. What is the ratio of the CO2 emissions (% of total fuel combustion) of Turkmenistan in 2005 to that in 2009?
Give a very brief answer. 1.48. What is the ratio of the CO2 emissions (% of total fuel combustion) in Thailand in 2006 to that in 2007?
Offer a terse response. 0.96. What is the ratio of the CO2 emissions (% of total fuel combustion) in Turkey in 2006 to that in 2007?
Keep it short and to the point. 0.97. What is the ratio of the CO2 emissions (% of total fuel combustion) in Turkmenistan in 2006 to that in 2007?
Make the answer very short. 1.07. What is the ratio of the CO2 emissions (% of total fuel combustion) in East Asia (developing only) in 2006 to that in 2008?
Keep it short and to the point. 0.98. What is the ratio of the CO2 emissions (% of total fuel combustion) in Thailand in 2006 to that in 2008?
Your response must be concise. 1.04. What is the ratio of the CO2 emissions (% of total fuel combustion) of Turkey in 2006 to that in 2008?
Your answer should be compact. 1.03. What is the ratio of the CO2 emissions (% of total fuel combustion) in Turkmenistan in 2006 to that in 2008?
Your response must be concise. 1.05. What is the ratio of the CO2 emissions (% of total fuel combustion) in East Asia (developing only) in 2006 to that in 2009?
Make the answer very short. 0.96. What is the ratio of the CO2 emissions (% of total fuel combustion) of Thailand in 2006 to that in 2009?
Offer a very short reply. 0.95. What is the ratio of the CO2 emissions (% of total fuel combustion) in Turkey in 2006 to that in 2009?
Offer a terse response. 1.01. What is the ratio of the CO2 emissions (% of total fuel combustion) of Turkmenistan in 2006 to that in 2009?
Provide a succinct answer. 1.42. What is the ratio of the CO2 emissions (% of total fuel combustion) of Thailand in 2007 to that in 2008?
Keep it short and to the point. 1.07. What is the ratio of the CO2 emissions (% of total fuel combustion) in Turkey in 2007 to that in 2008?
Ensure brevity in your answer.  1.06. What is the ratio of the CO2 emissions (% of total fuel combustion) of Turkmenistan in 2007 to that in 2008?
Provide a succinct answer. 0.98. What is the ratio of the CO2 emissions (% of total fuel combustion) in East Asia (developing only) in 2007 to that in 2009?
Provide a succinct answer. 0.97. What is the ratio of the CO2 emissions (% of total fuel combustion) in Thailand in 2007 to that in 2009?
Your response must be concise. 0.98. What is the ratio of the CO2 emissions (% of total fuel combustion) in Turkey in 2007 to that in 2009?
Offer a terse response. 1.04. What is the ratio of the CO2 emissions (% of total fuel combustion) in Turkmenistan in 2007 to that in 2009?
Make the answer very short. 1.33. What is the ratio of the CO2 emissions (% of total fuel combustion) of East Asia (developing only) in 2008 to that in 2009?
Your answer should be very brief. 0.98. What is the ratio of the CO2 emissions (% of total fuel combustion) in Thailand in 2008 to that in 2009?
Your answer should be very brief. 0.91. What is the ratio of the CO2 emissions (% of total fuel combustion) in Turkey in 2008 to that in 2009?
Offer a very short reply. 0.98. What is the ratio of the CO2 emissions (% of total fuel combustion) of Turkmenistan in 2008 to that in 2009?
Ensure brevity in your answer.  1.35. What is the difference between the highest and the second highest CO2 emissions (% of total fuel combustion) in East Asia (developing only)?
Your answer should be very brief. 0.45. What is the difference between the highest and the second highest CO2 emissions (% of total fuel combustion) of Thailand?
Make the answer very short. 0.78. What is the difference between the highest and the second highest CO2 emissions (% of total fuel combustion) in Turkey?
Offer a terse response. 0.52. What is the difference between the highest and the second highest CO2 emissions (% of total fuel combustion) of Turkmenistan?
Offer a very short reply. 0.13. What is the difference between the highest and the lowest CO2 emissions (% of total fuel combustion) of East Asia (developing only)?
Ensure brevity in your answer.  0.84. What is the difference between the highest and the lowest CO2 emissions (% of total fuel combustion) of Thailand?
Your answer should be compact. 3.56. What is the difference between the highest and the lowest CO2 emissions (% of total fuel combustion) in Turkmenistan?
Provide a short and direct response. 4.48. 